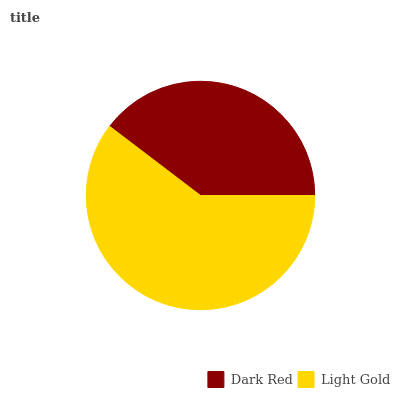Is Dark Red the minimum?
Answer yes or no. Yes. Is Light Gold the maximum?
Answer yes or no. Yes. Is Light Gold the minimum?
Answer yes or no. No. Is Light Gold greater than Dark Red?
Answer yes or no. Yes. Is Dark Red less than Light Gold?
Answer yes or no. Yes. Is Dark Red greater than Light Gold?
Answer yes or no. No. Is Light Gold less than Dark Red?
Answer yes or no. No. Is Light Gold the high median?
Answer yes or no. Yes. Is Dark Red the low median?
Answer yes or no. Yes. Is Dark Red the high median?
Answer yes or no. No. Is Light Gold the low median?
Answer yes or no. No. 